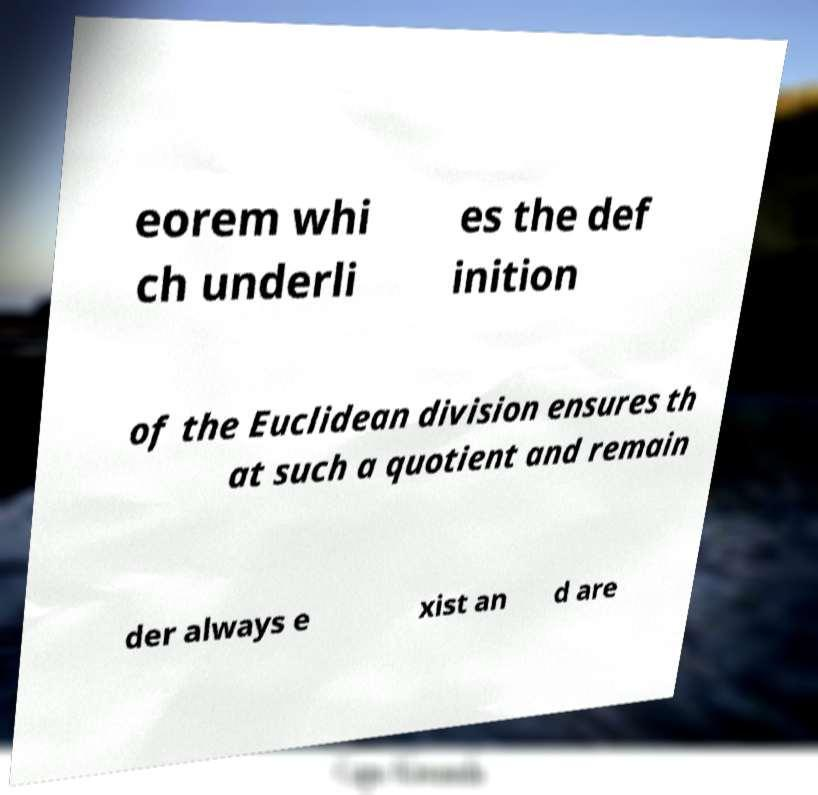There's text embedded in this image that I need extracted. Can you transcribe it verbatim? eorem whi ch underli es the def inition of the Euclidean division ensures th at such a quotient and remain der always e xist an d are 